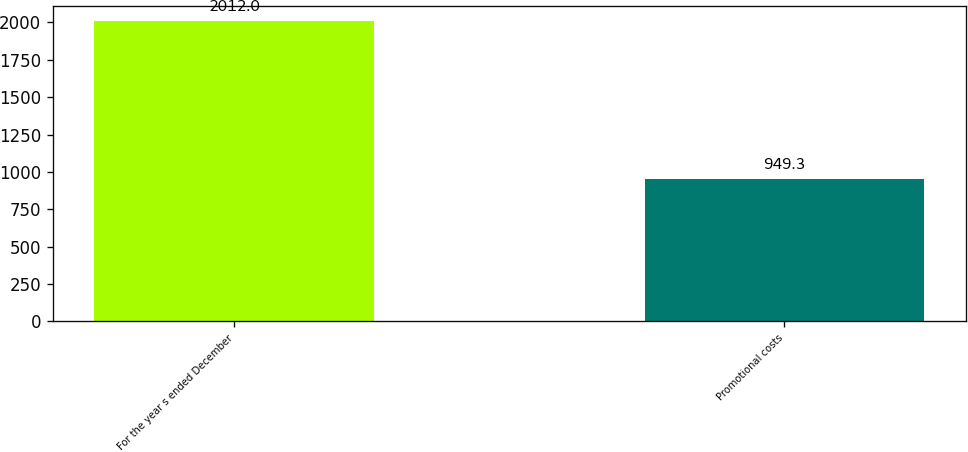Convert chart to OTSL. <chart><loc_0><loc_0><loc_500><loc_500><bar_chart><fcel>For the year s ended December<fcel>Promotional costs<nl><fcel>2012<fcel>949.3<nl></chart> 